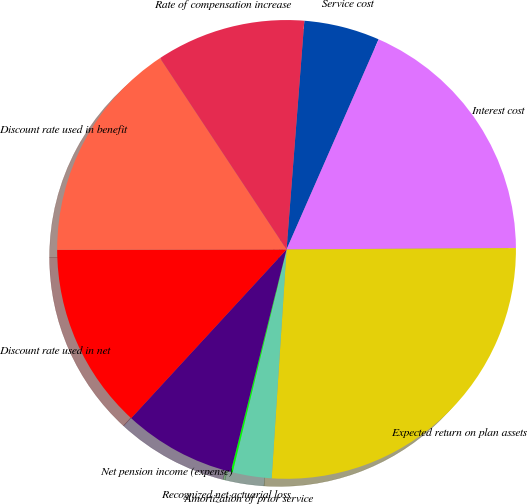<chart> <loc_0><loc_0><loc_500><loc_500><pie_chart><fcel>Service cost<fcel>Interest cost<fcel>Expected return on plan assets<fcel>Amortization of prior service<fcel>Recognized net actuarial loss<fcel>Net pension income (expense)<fcel>Discount rate used in net<fcel>Discount rate used in benefit<fcel>Rate of compensation increase<nl><fcel>5.34%<fcel>18.33%<fcel>26.13%<fcel>2.74%<fcel>0.14%<fcel>7.93%<fcel>13.13%<fcel>15.73%<fcel>10.53%<nl></chart> 